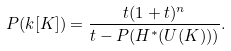<formula> <loc_0><loc_0><loc_500><loc_500>P ( k [ K ] ) = \frac { t ( 1 + t ) ^ { n } } { t - P ( H ^ { * } ( U ( K ) ) ) } .</formula> 